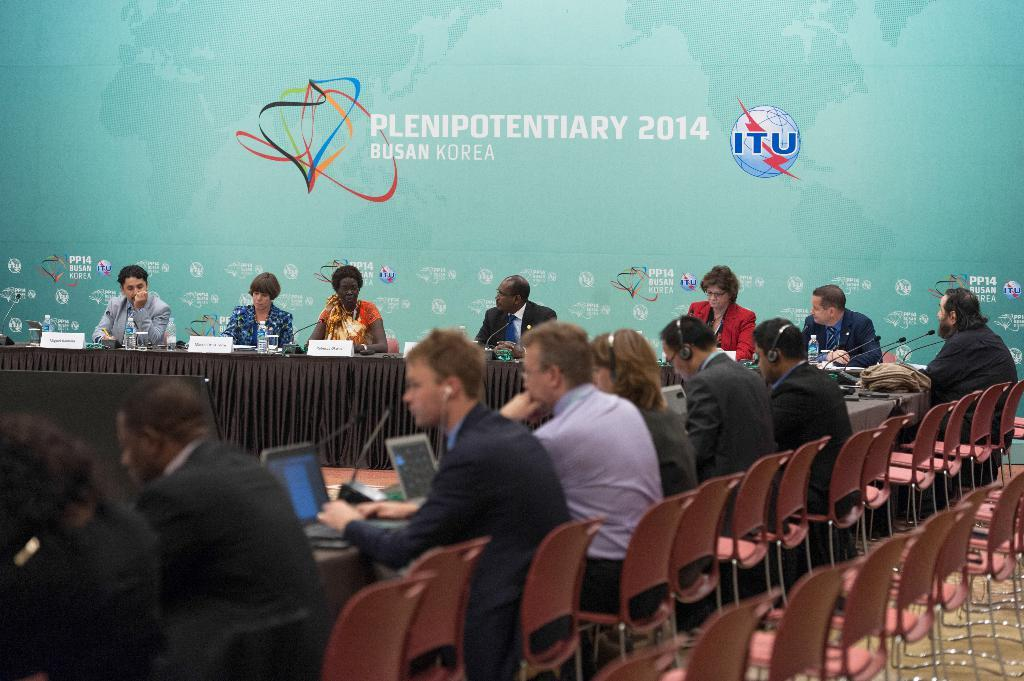What type of furniture is in the image? There is a table and chairs in the image. What items can be seen on the table? Water bottles, name boards, and pens are visible on the table. What are the people in the image doing? People are sitting on the chairs. In which direction is the water flowing in the image? There is no water flowing in the image; it only shows a table, chairs, and items on the table. 